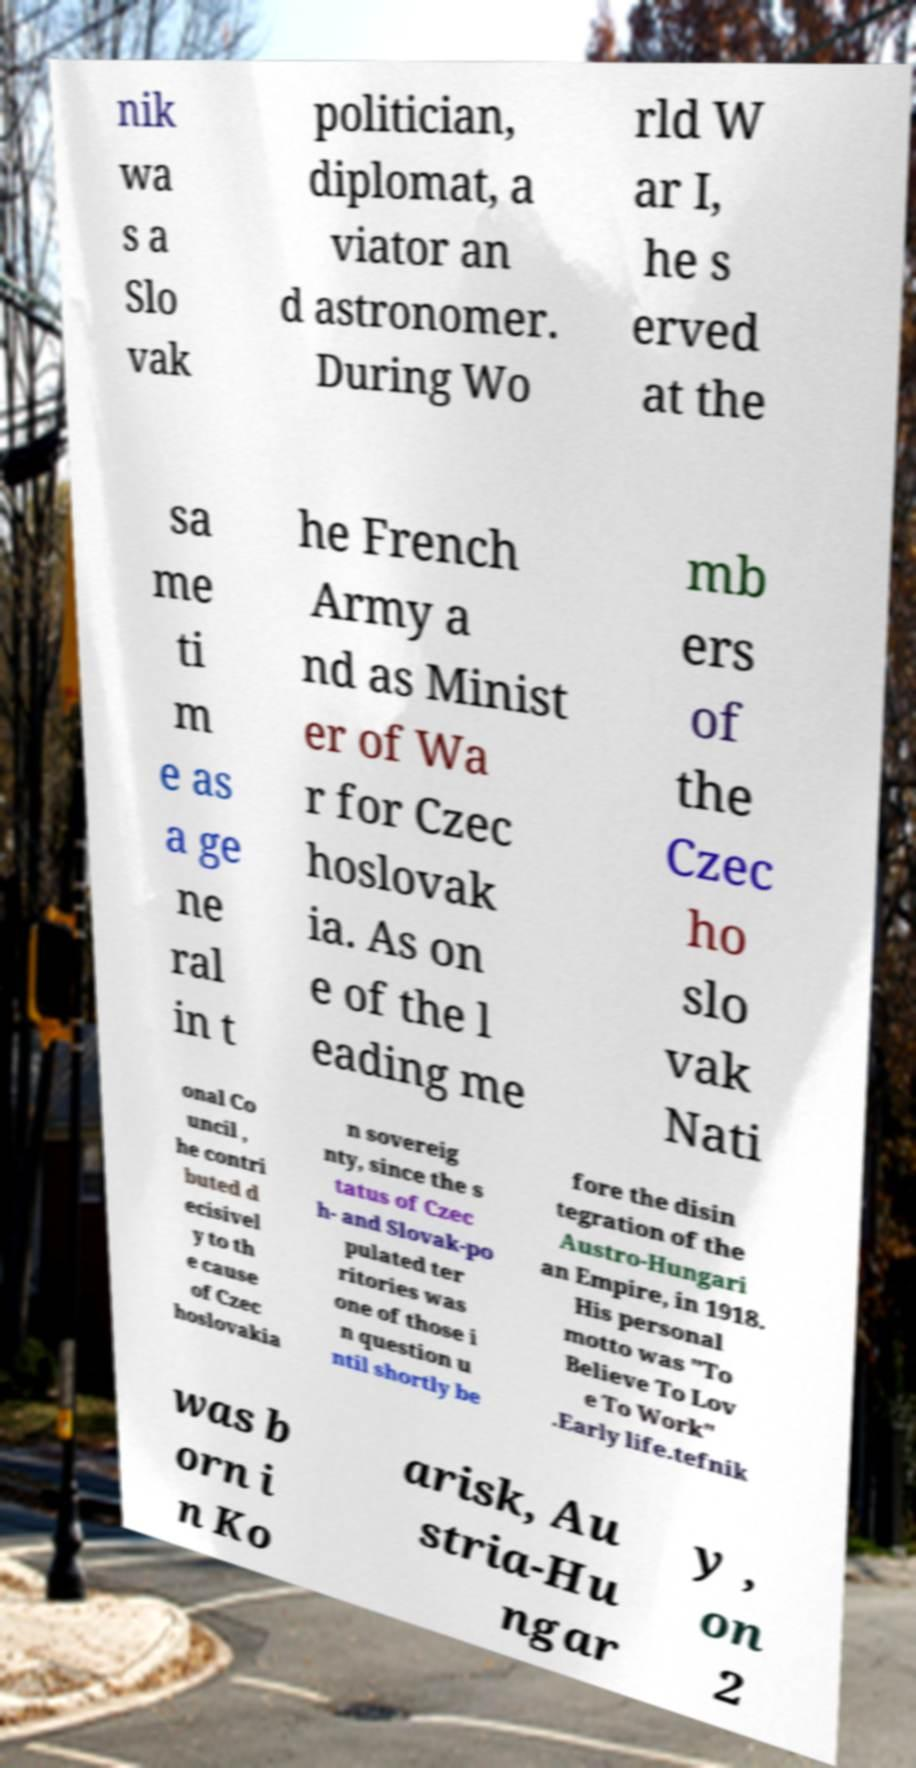Could you assist in decoding the text presented in this image and type it out clearly? nik wa s a Slo vak politician, diplomat, a viator an d astronomer. During Wo rld W ar I, he s erved at the sa me ti m e as a ge ne ral in t he French Army a nd as Minist er of Wa r for Czec hoslovak ia. As on e of the l eading me mb ers of the Czec ho slo vak Nati onal Co uncil , he contri buted d ecisivel y to th e cause of Czec hoslovakia n sovereig nty, since the s tatus of Czec h- and Slovak-po pulated ter ritories was one of those i n question u ntil shortly be fore the disin tegration of the Austro-Hungari an Empire, in 1918. His personal motto was "To Believe To Lov e To Work" .Early life.tefnik was b orn i n Ko arisk, Au stria-Hu ngar y , on 2 